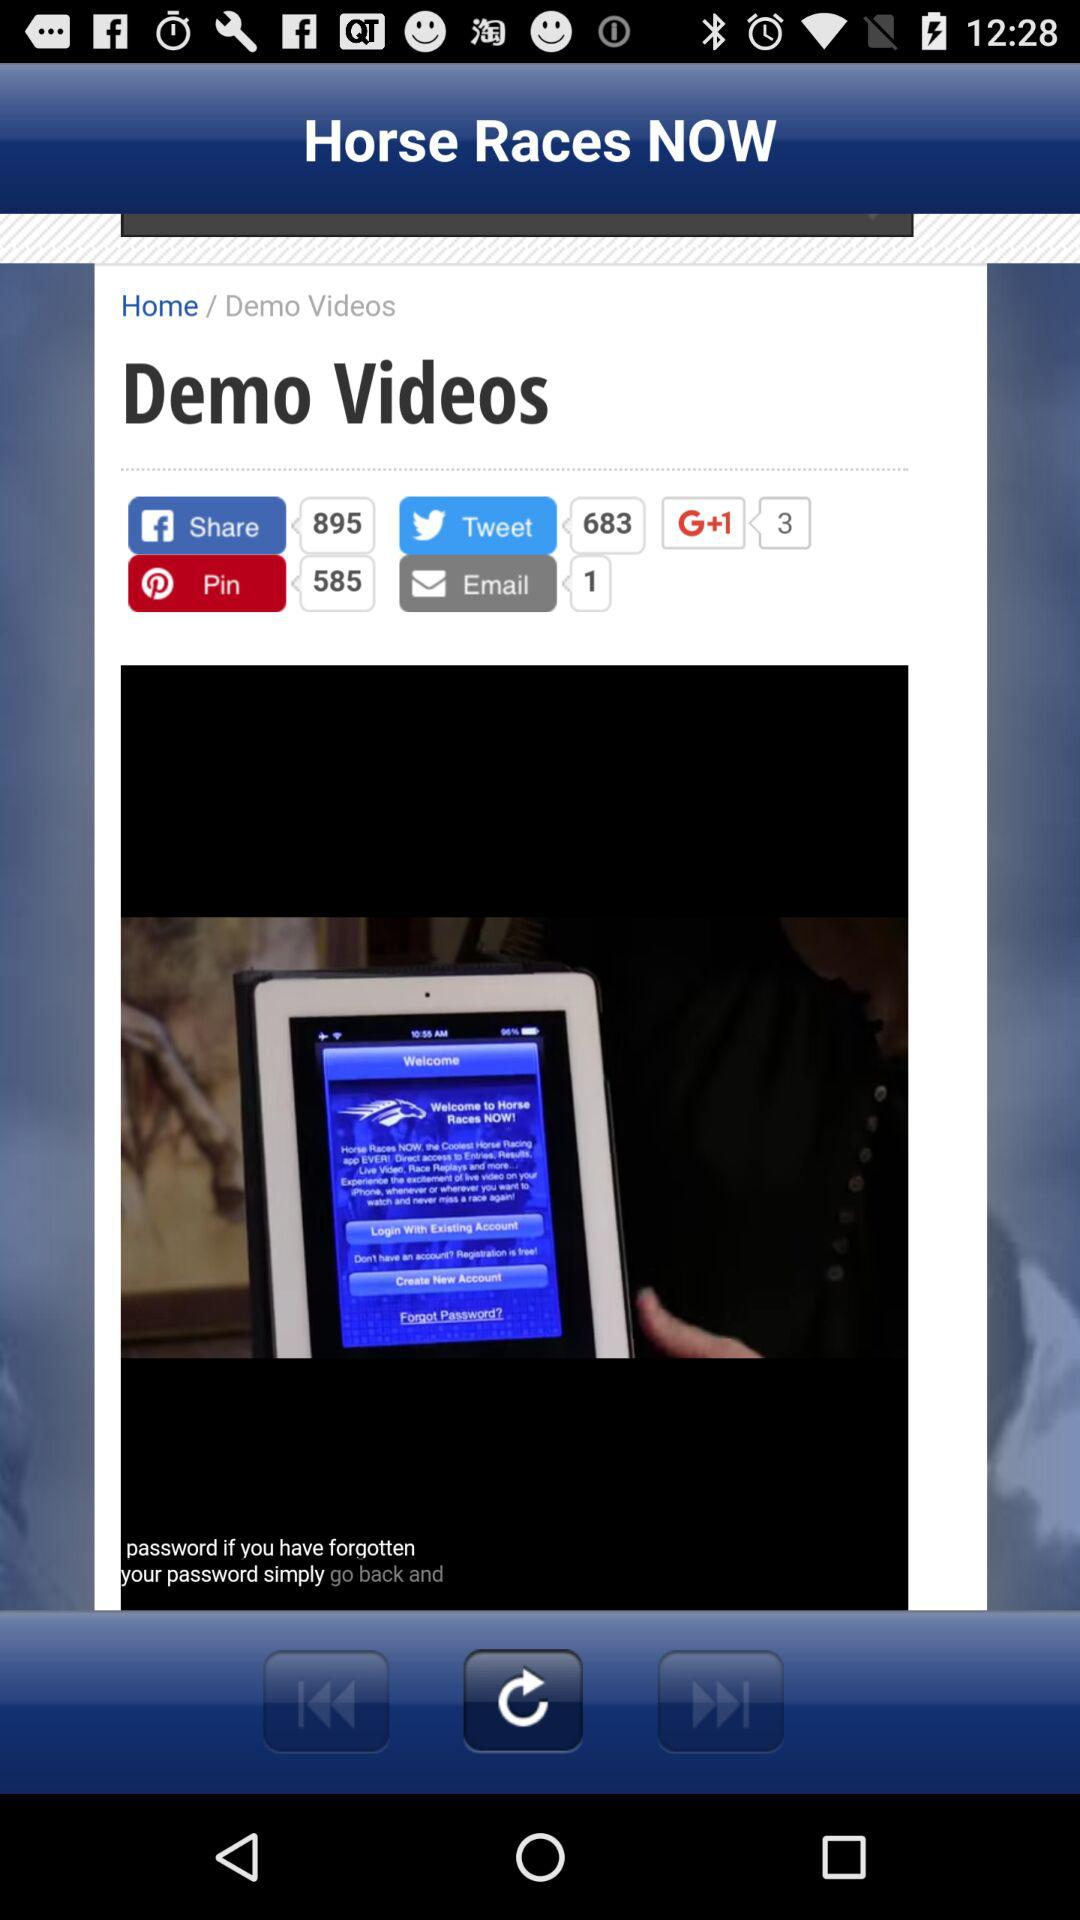How many "Facebook" shares are there? There are 895 "Facebook" shares. 